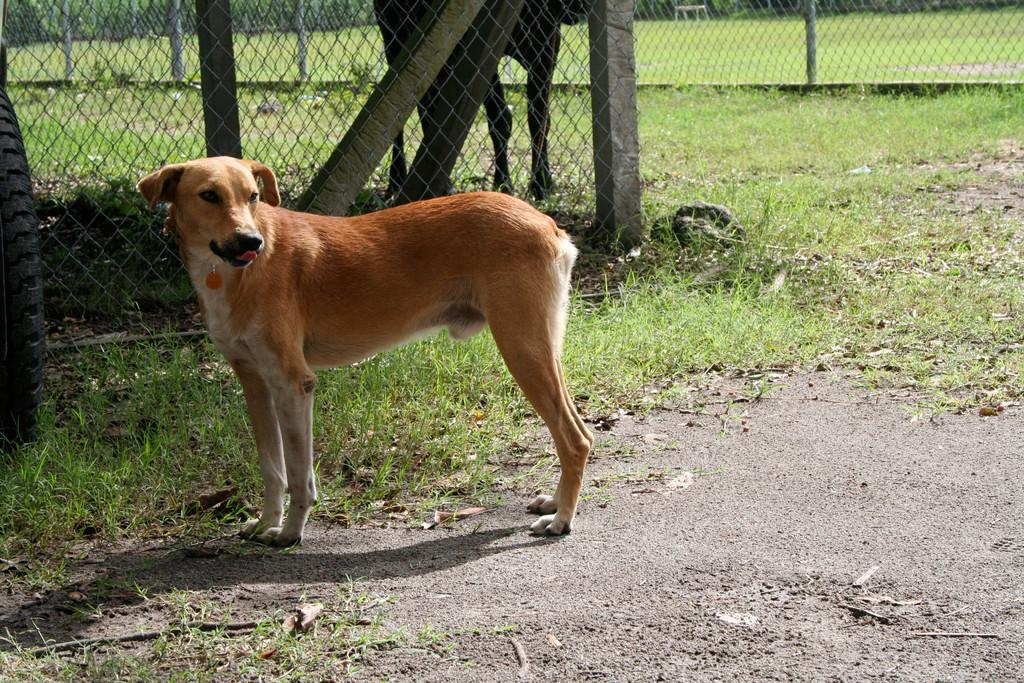What type of animal can be seen in the image? There is a dog in the image. What is the dog doing in the image? The dog is standing on the ground. What is visible behind the dog? There is a fence behind the dog. What type of surface is the dog standing on? There is grass and sand on the ground. What other animal can be seen in the image? There is another animal beside the fence. What type of desk can be seen in the image? There is no desk present in the image. What type of education is being provided to the animals in the image? There is no indication of any educational activity in the image. 